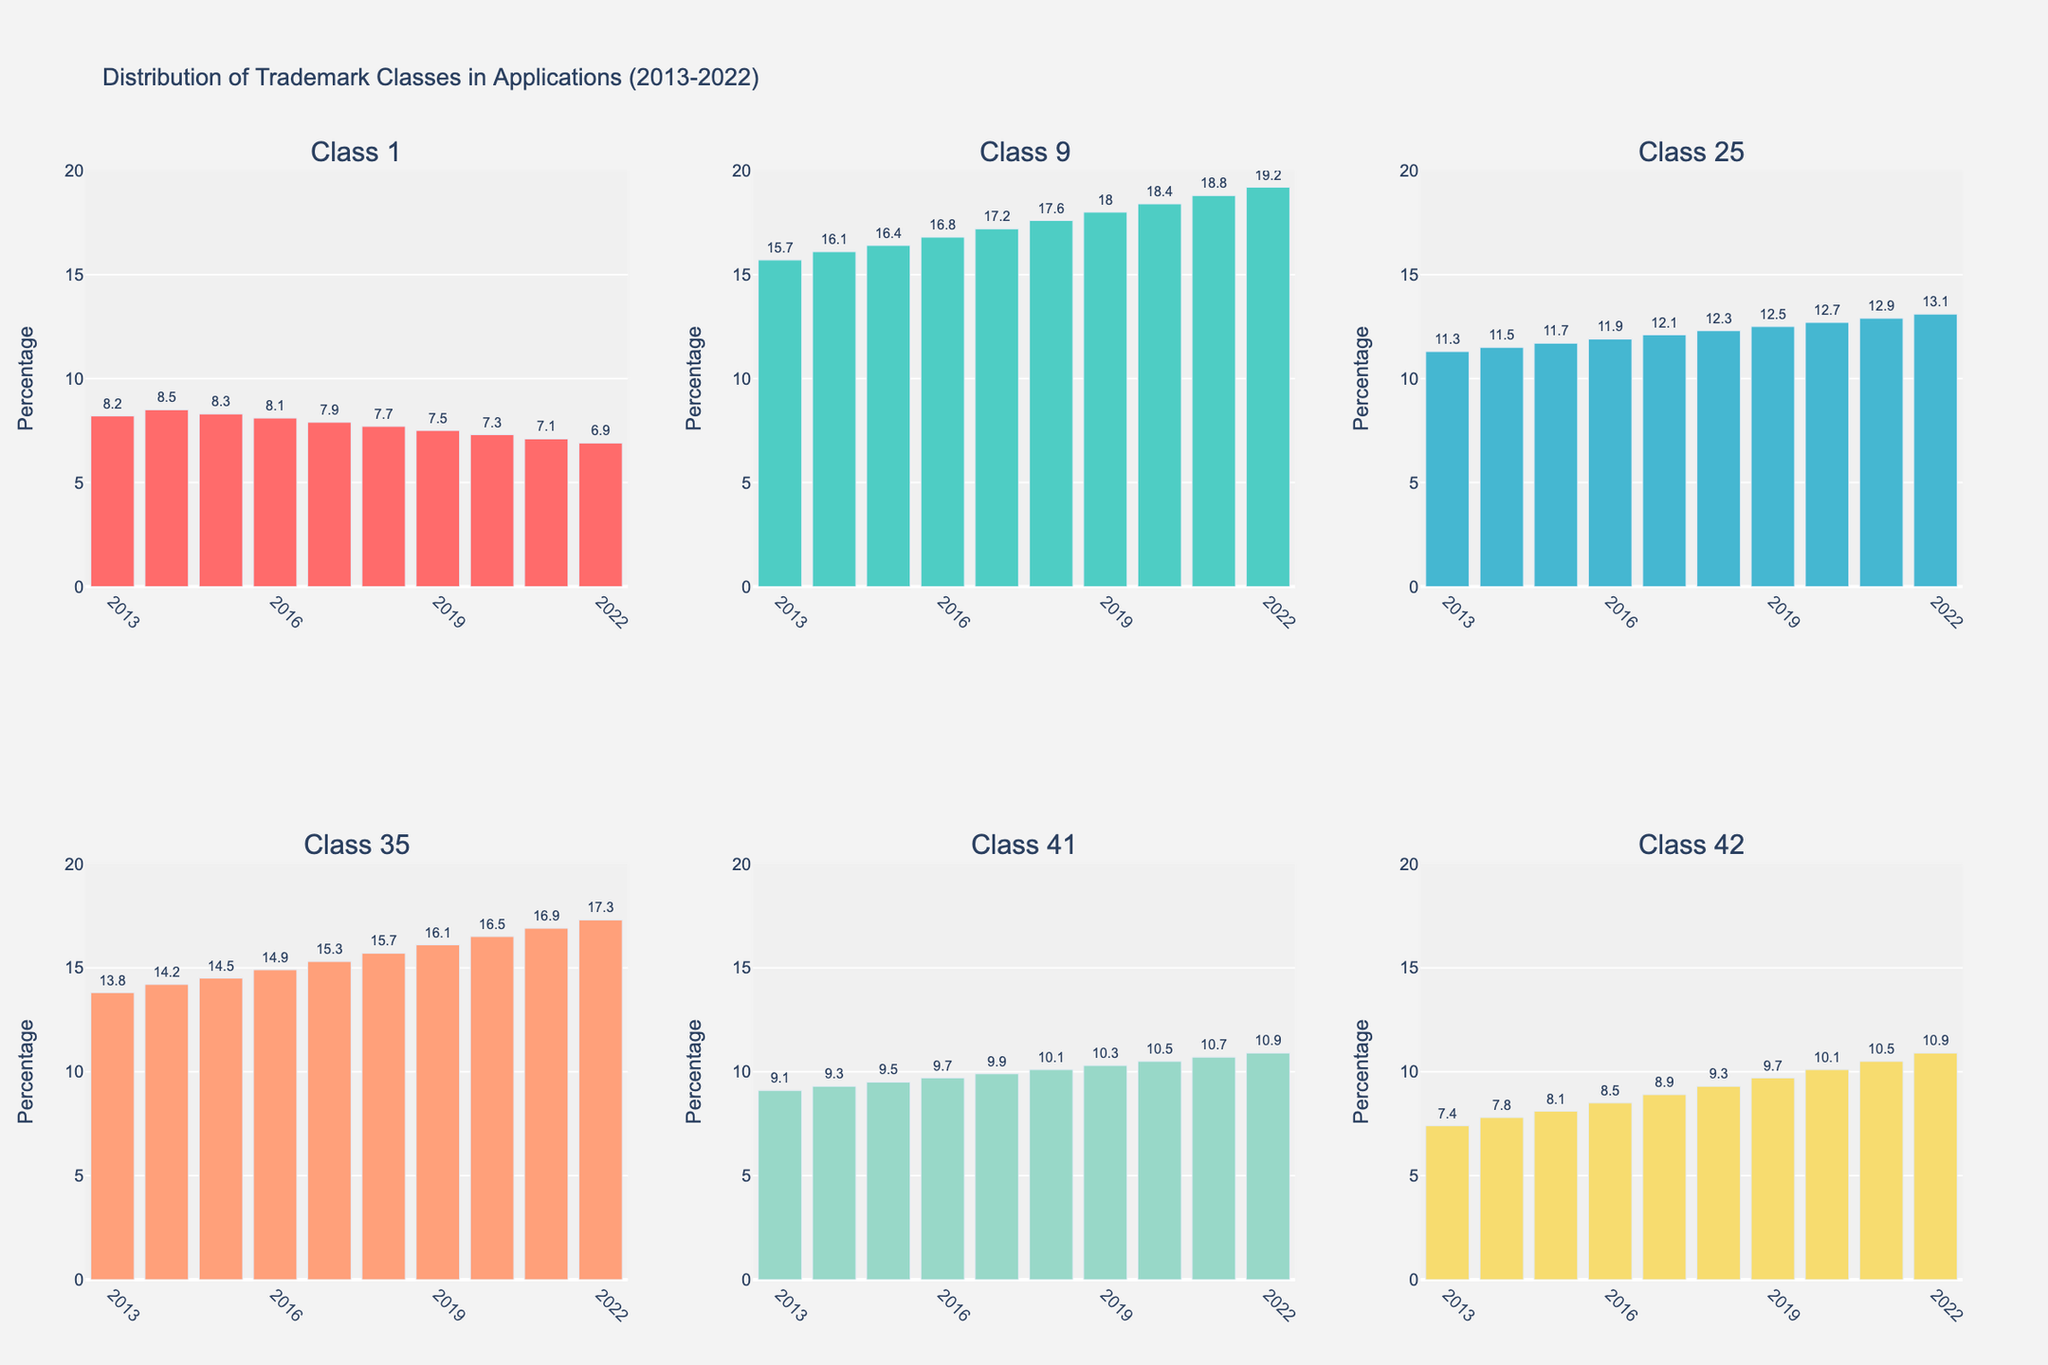What's the overall trend of Class 9 from 2013 to 2022? The percentage for Class 9 consistently increased every year from 15.7% in 2013 to 19.2% in 2022. This indicates a steady rise in trademark applications for Class 9 over the past decade.
Answer: Increasing Which class had the highest percentage in 2022? In 2022, Class 9 had the highest percentage of trademark applications, with a value of 19.2%. This can be seen by comparing the heights of the bars for each class in 2022.
Answer: Class 9 Between Class 25 and Class 35, which had a greater increase in percentage from 2013 to 2022? For Class 25, the increase from 2013 to 2022 is 13.1% - 11.3% = 1.8%. For Class 35, the increase from 2013 to 2022 is 17.3% - 13.8% = 3.5%. Thus, Class 35 had a greater increase.
Answer: Class 35 What is the average percentage for Class 41 over the decade? The percentages for Class 41 over the years are [9.1, 9.3, 9.5, 9.7, 9.9, 10.1, 10.3, 10.5, 10.7, 10.9]. Summing them up gives 99, and dividing by 10 (the number of years) gives an average of 9.9%.
Answer: 9.9% Which classes had a consistent increase in their percentages each year? Observing the bars for each year, Class 9, Class 35, Class 41, and Class 42 show a consistent increase every year from 2013 to 2022. Classes 1 and 25 do not show such consistency.
Answer: Class 9, Class 35, Class 41, Class 42 How much did the percentage for Class 1 decrease from 2013 to 2022? The percentage for Class 1 in 2013 was 8.2%, and in 2022 it was 6.9%. The decrease is 8.2% - 6.9% = 1.3%.
Answer: 1.3% Which class had the smallest variation in percentages over the decade? To find the smallest variation, we calculate the range for each class. Class 1 has values ranging from 6.9% to 8.5%, a range of 1.6. Class 9 ranges from 15.7% to 19.2%, a range of 3.5. Class 25 ranges from 11.3% to 13.1%, a range of 1.8. Class 35 ranges from 13.8% to 17.3%, a range of 3.5. Class 41 ranges from 9.1% to 10.9%, a range of 1.8. Class 42 ranges from 7.4% to 10.9%, a range of 3.5. Therefore, Class 1 has the smallest variation.
Answer: Class 1 Which class saw the most significant increase in trademark applications from 2013 to 2022? The difference in percentages from 2013 to 2022 for each class is calculated. Class 9 increased by 3.5%, Class 35 by 3.5%, Class 41 by 1.8%, and Class 42 by 3.5%. All these classes (Class 9, Class 35, and Class 42) saw the most significant increases.
Answer: Class 9, Class 35, Class 42 Is there any class for which the percentage of trademark applications has always been above 10%? Observing each subplot, only Class 9 has its percentage of applications above 10% for every year from 2013 to 2022.
Answer: Class 9 